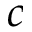Convert formula to latex. <formula><loc_0><loc_0><loc_500><loc_500>c</formula> 